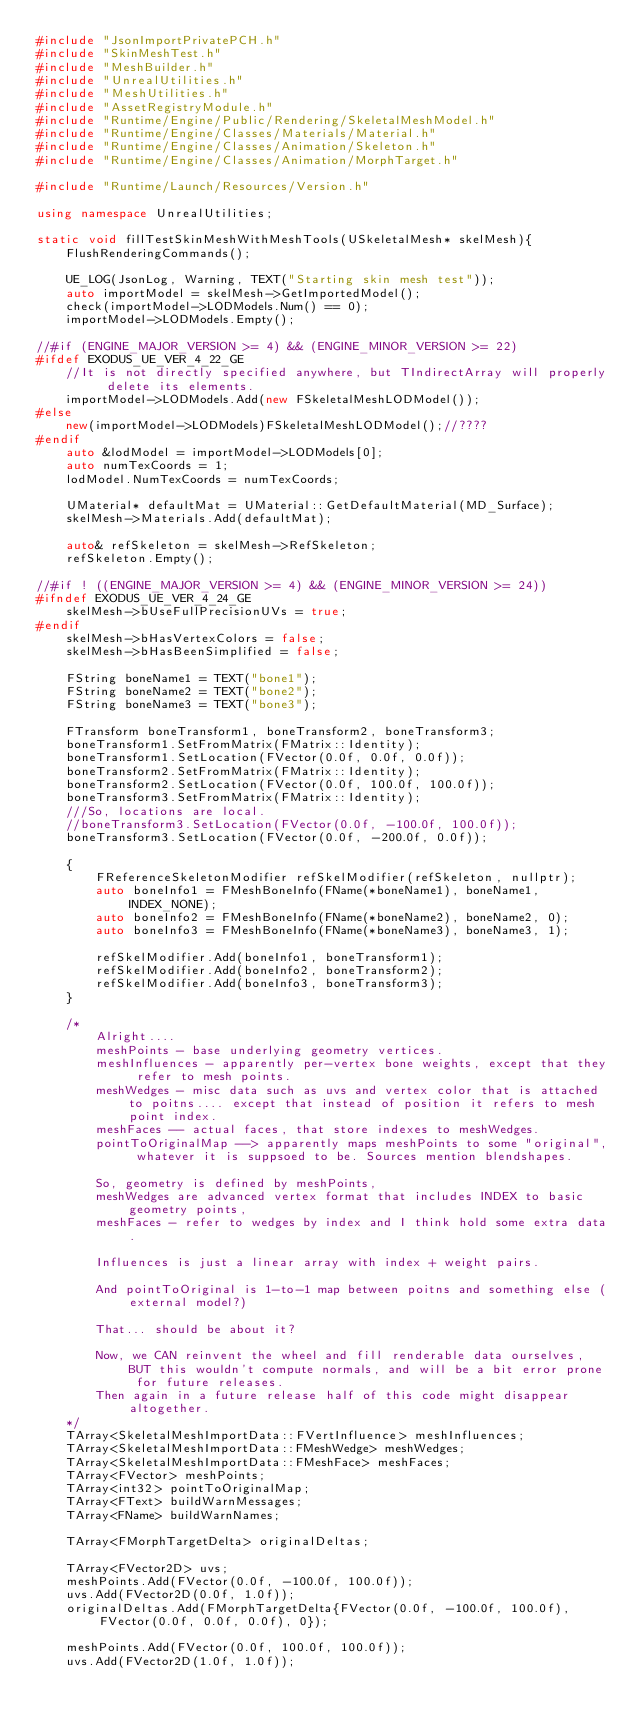Convert code to text. <code><loc_0><loc_0><loc_500><loc_500><_C++_>#include "JsonImportPrivatePCH.h"
#include "SkinMeshTest.h"
#include "MeshBuilder.h"
#include "UnrealUtilities.h"
#include "MeshUtilities.h"
#include "AssetRegistryModule.h"
#include "Runtime/Engine/Public/Rendering/SkeletalMeshModel.h"
#include "Runtime/Engine/Classes/Materials/Material.h"
#include "Runtime/Engine/Classes/Animation/Skeleton.h"
#include "Runtime/Engine/Classes/Animation/MorphTarget.h"

#include "Runtime/Launch/Resources/Version.h"

using namespace UnrealUtilities;

static void fillTestSkinMeshWithMeshTools(USkeletalMesh* skelMesh){
	FlushRenderingCommands();

	UE_LOG(JsonLog, Warning, TEXT("Starting skin mesh test"));
	auto importModel = skelMesh->GetImportedModel();
	check(importModel->LODModels.Num() == 0);
	importModel->LODModels.Empty();

//#if (ENGINE_MAJOR_VERSION >= 4) && (ENGINE_MINOR_VERSION >= 22)
#ifdef EXODUS_UE_VER_4_22_GE
	//It is not directly specified anywhere, but TIndirectArray will properly delete its elements.
	importModel->LODModels.Add(new FSkeletalMeshLODModel());
#else
	new(importModel->LODModels)FSkeletalMeshLODModel();//????
#endif
	auto &lodModel = importModel->LODModels[0];
	auto numTexCoords = 1;
	lodModel.NumTexCoords = numTexCoords;

	UMaterial* defaultMat = UMaterial::GetDefaultMaterial(MD_Surface);
	skelMesh->Materials.Add(defaultMat);

	auto& refSkeleton = skelMesh->RefSkeleton;
	refSkeleton.Empty();

//#if ! ((ENGINE_MAJOR_VERSION >= 4) && (ENGINE_MINOR_VERSION >= 24))
#ifndef EXODUS_UE_VER_4_24_GE
	skelMesh->bUseFullPrecisionUVs = true;
#endif
	skelMesh->bHasVertexColors = false;
	skelMesh->bHasBeenSimplified = false;

	FString boneName1 = TEXT("bone1");
	FString boneName2 = TEXT("bone2");
	FString boneName3 = TEXT("bone3");

	FTransform boneTransform1, boneTransform2, boneTransform3;
	boneTransform1.SetFromMatrix(FMatrix::Identity);
	boneTransform1.SetLocation(FVector(0.0f, 0.0f, 0.0f));
	boneTransform2.SetFromMatrix(FMatrix::Identity);
	boneTransform2.SetLocation(FVector(0.0f, 100.0f, 100.0f));
	boneTransform3.SetFromMatrix(FMatrix::Identity);
	///So, locations are local.
	//boneTransform3.SetLocation(FVector(0.0f, -100.0f, 100.0f));
	boneTransform3.SetLocation(FVector(0.0f, -200.0f, 0.0f));

	{
		FReferenceSkeletonModifier refSkelModifier(refSkeleton, nullptr);
		auto boneInfo1 = FMeshBoneInfo(FName(*boneName1), boneName1, INDEX_NONE);
		auto boneInfo2 = FMeshBoneInfo(FName(*boneName2), boneName2, 0);
		auto boneInfo3 = FMeshBoneInfo(FName(*boneName3), boneName3, 1);

		refSkelModifier.Add(boneInfo1, boneTransform1);
		refSkelModifier.Add(boneInfo2, boneTransform2);
		refSkelModifier.Add(boneInfo3, boneTransform3);
	}

	/*
		Alright....
		meshPoints - base underlying geometry vertices.
		meshInfluences - apparently per-vertex bone weights, except that they refer to mesh points.
		meshWedges - misc data such as uvs and vertex color that is attached to poitns.... except that instead of position it refers to mesh point index.
		meshFaces -- actual faces, that store indexes to meshWedges.
		pointToOriginalMap --> apparently maps meshPoints to some "original", whatever it is suppsoed to be. Sources mention blendshapes.

		So, geometry is defined by meshPoints, 
		meshWedges are advanced vertex format that includes INDEX to basic geometry points,
		meshFaces - refer to wedges by index and I think hold some extra data.

		Influences is just a linear array with index + weight pairs. 

		And pointToOriginal is 1-to-1 map between poitns and something else (external model?)

		That... should be about it?

		Now, we CAN reinvent the wheel and fill renderable data ourselves, BUT this wouldn't compute normals, and will be a bit error prone for future releases.
		Then again in a future release half of this code might disappear altogether.
	*/
	TArray<SkeletalMeshImportData::FVertInfluence> meshInfluences;
	TArray<SkeletalMeshImportData::FMeshWedge> meshWedges;
	TArray<SkeletalMeshImportData::FMeshFace> meshFaces;
	TArray<FVector> meshPoints;
	TArray<int32> pointToOriginalMap;
	TArray<FText> buildWarnMessages;
	TArray<FName> buildWarnNames;

	TArray<FMorphTargetDelta> originalDeltas;

	TArray<FVector2D> uvs;
	meshPoints.Add(FVector(0.0f, -100.0f, 100.0f));
	uvs.Add(FVector2D(0.0f, 1.0f));
	originalDeltas.Add(FMorphTargetDelta{FVector(0.0f, -100.0f, 100.0f), FVector(0.0f, 0.0f, 0.0f), 0});

	meshPoints.Add(FVector(0.0f, 100.0f, 100.0f));
	uvs.Add(FVector2D(1.0f, 1.0f));</code> 